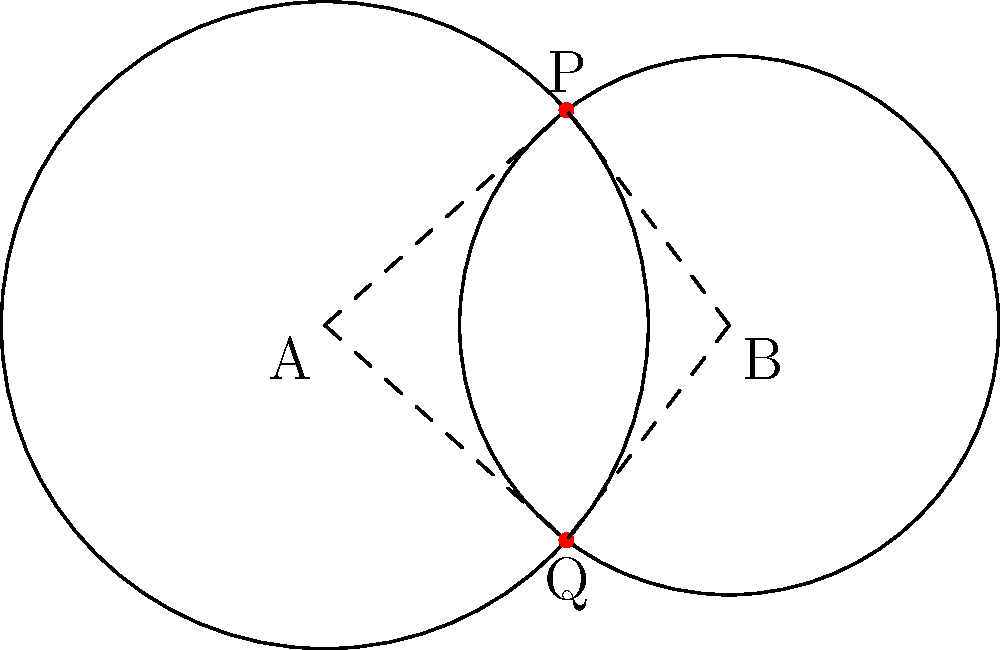Two circular plasmids are represented by overlapping circles with centers A and B. The radius of circle A is 1.2 units, and the radius of circle B is 1 unit. The distance between their centers is 1.5 units. Calculate the area of the region where the plasmids overlap (i.e., the area of intersection between the two circles). To find the area of intersection between two circles, we can use the following steps:

1. First, we need to calculate the angle $\theta$ at the center of each circle formed by the line joining the centers and the line to one of the intersection points.

For circle A: $\cos \theta_A = \frac{1.5^2 + 1.2^2 - 1^2}{2 \cdot 1.5 \cdot 1.2} = 0.7292$
$\theta_A = \arccos(0.7292) = 0.7540$ radians

For circle B: $\cos \theta_B = \frac{1.5^2 + 1^2 - 1.2^2}{2 \cdot 1.5 \cdot 1} = 0.5167$
$\theta_B = \arccos(0.5167) = 1.0210$ radians

2. Now, we can calculate the area of each sector:

Area of sector A $= \frac{1}{2} \cdot 1.2^2 \cdot 2\theta_A = 0.5433$ square units
Area of sector B $= \frac{1}{2} \cdot 1^2 \cdot 2\theta_B = 0.5105$ square units

3. Next, we calculate the area of the triangles formed by the centers and the intersection points:

Area of triangle $= \frac{1}{2} \cdot 1.5 \cdot 1.2 \sin(\theta_A) = 0.4158$ square units

4. The area of intersection is the sum of the two sectors minus the area of the two triangles:

Area of intersection $= (0.5433 + 0.5105) - 2(0.4158) = 0.2222$ square units
Answer: $0.2222$ square units 